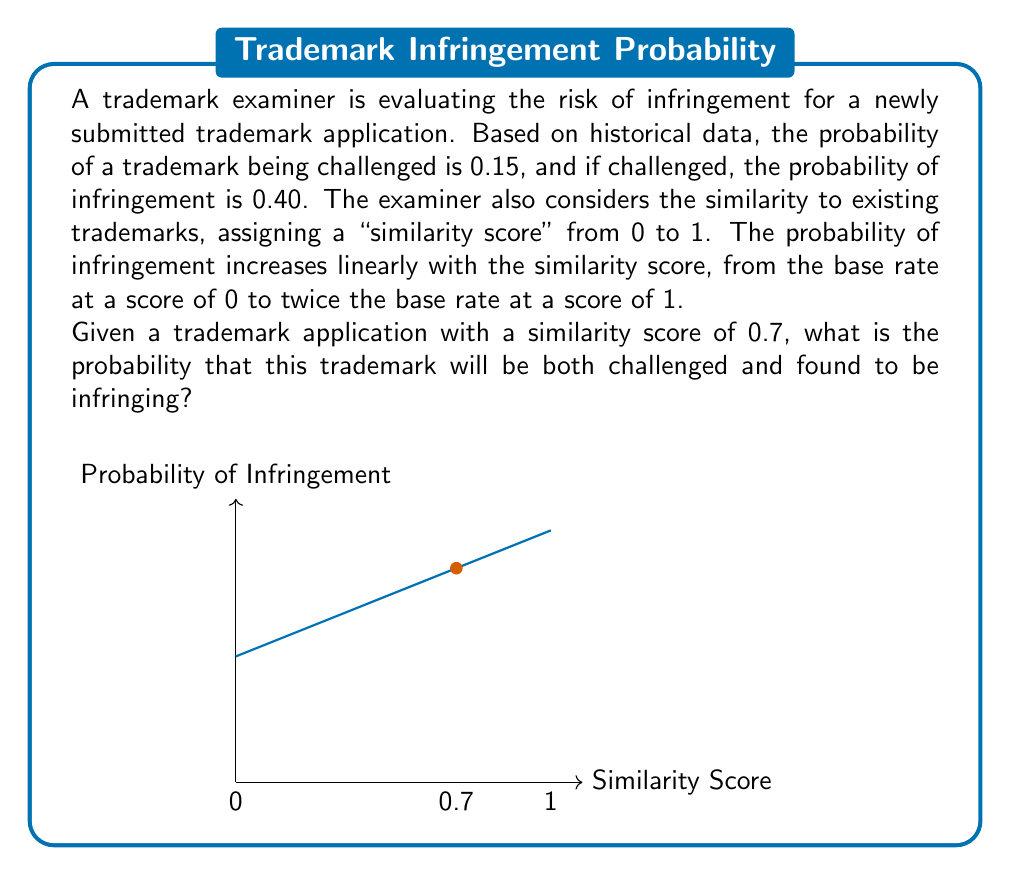What is the answer to this math problem? Let's approach this step-by-step:

1) First, we need to calculate the probability of infringement given the similarity score of 0.7.

   The base rate of infringement if challenged is 0.40.
   At a similarity score of 1, this rate doubles to 0.80.
   
   We can express this as a linear function:
   $$P(\text{Infringement}|\text{Challenged}) = 0.40 + 0.40s$$
   where $s$ is the similarity score.

2) For $s = 0.7$:
   $$P(\text{Infringement}|\text{Challenged}) = 0.40 + 0.40(0.7) = 0.40 + 0.28 = 0.68$$

3) Now we have:
   $P(\text{Challenged}) = 0.15$
   $P(\text{Infringement}|\text{Challenged}) = 0.68$

4) To find the probability of both events occurring, we multiply these probabilities:

   $$P(\text{Challenged and Infringing}) = P(\text{Challenged}) \times P(\text{Infringement}|\text{Challenged})$$
   $$= 0.15 \times 0.68 = 0.102$$

Therefore, the probability that this trademark will be both challenged and found to be infringing is 0.102 or 10.2%.
Answer: 0.102 